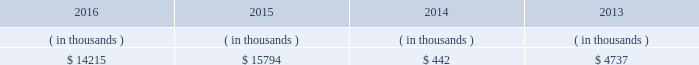Entergy new orleans , inc .
And subsidiaries management 2019s financial discussion and analysis entergy new orleans 2019s receivables from the money pool were as follows as of december 31 for each of the following years. .
See note 4 to the financial statements for a description of the money pool .
Entergy new orleans has a credit facility in the amount of $ 25 million scheduled to expire in november 2018 .
The credit facility allows entergy new orleans to issue letters of credit against $ 10 million of the borrowing capacity of the facility .
As of december 31 , 2016 , there were no cash borrowings and a $ 0.8 million letter of credit was outstanding under the facility .
In addition , entergy new orleans is a party to an uncommitted letter of credit facility as a means to post collateral to support its obligations under miso .
As of december 31 , 2016 , a $ 6.2 million letter of credit was outstanding under entergy new orleans 2019s letter of credit facility .
See note 4 to the financial statements for additional discussion of the credit facilities .
Entergy new orleans obtained authorization from the ferc through october 2017 for short-term borrowings not to exceed an aggregate amount of $ 100 million at any time outstanding .
See note 4 to the financial statements for further discussion of entergy new orleans 2019s short-term borrowing limits .
The long-term securities issuances of entergy new orleans are limited to amounts authorized by the city council , and the current authorization extends through june 2018 .
State and local rate regulation the rates that entergy new orleans charges for electricity and natural gas significantly influence its financial position , results of operations , and liquidity .
Entergy new orleans is regulated and the rates charged to its customers are determined in regulatory proceedings .
A governmental agency , the city council , is primarily responsible for approval of the rates charged to customers .
Retail rates see 201calgiers asset transfer 201d below for discussion of the transfer from entergy louisiana to entergy new orleans of certain assets that serve algiers customers .
In march 2013 , entergy louisiana filed a rate case for the algiers area , which is in new orleans and is regulated by the city council .
Entergy louisiana requested a rate increase of $ 13 million over three years , including a 10.4% ( 10.4 % ) return on common equity and a formula rate plan mechanism identical to its lpsc request .
In january 2014 the city council advisors filed direct testimony recommending a rate increase of $ 5.56 million over three years , including an 8.13% ( 8.13 % ) return on common equity .
In june 2014 the city council unanimously approved a settlement that includes the following : 2022 a $ 9.3 million base rate revenue increase to be phased in on a levelized basis over four years ; 2022 recovery of an additional $ 853 thousand annually through a miso recovery rider ; and 2022 the adoption of a four-year formula rate plan requiring the filing of annual evaluation reports in may of each year , commencing may 2015 , with resulting rates being implemented in october of each year .
The formula rate plan includes a midpoint target authorized return on common equity of 9.95% ( 9.95 % ) with a +/- 40 basis point bandwidth .
The rate increase was effective with bills rendered on and after the first billing cycle of july 2014 .
Additional compliance filings were made with the city council in october 2014 for approval of the form of certain rate riders , including among others , a ninemile 6 non-fuel cost recovery interim rider , allowing for contemporaneous recovery of capacity .
What is the maximum target authorized return on common equity under the formula rate plan? 
Computations: ((40 / 100) + 9.95)
Answer: 10.35. 